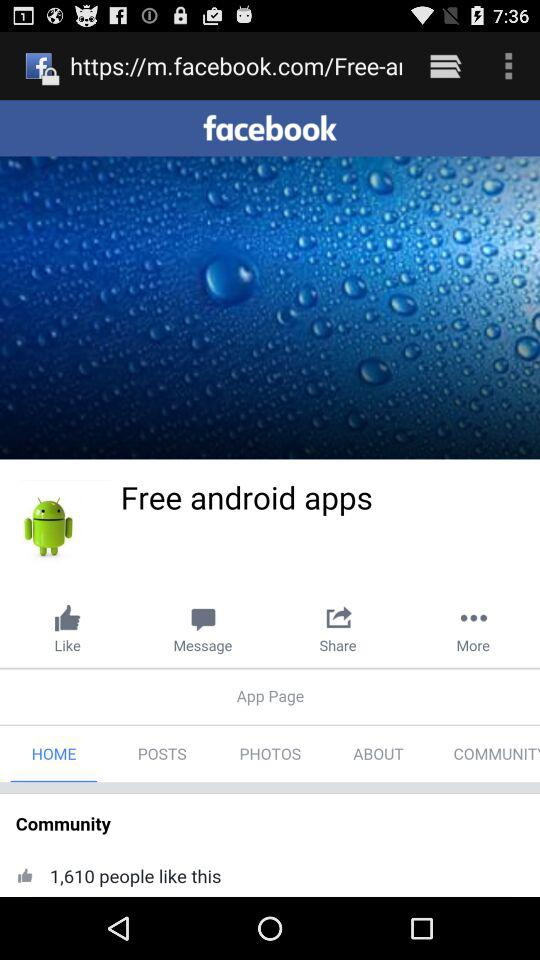What is the name of the application? The name of the application is "facebook". 